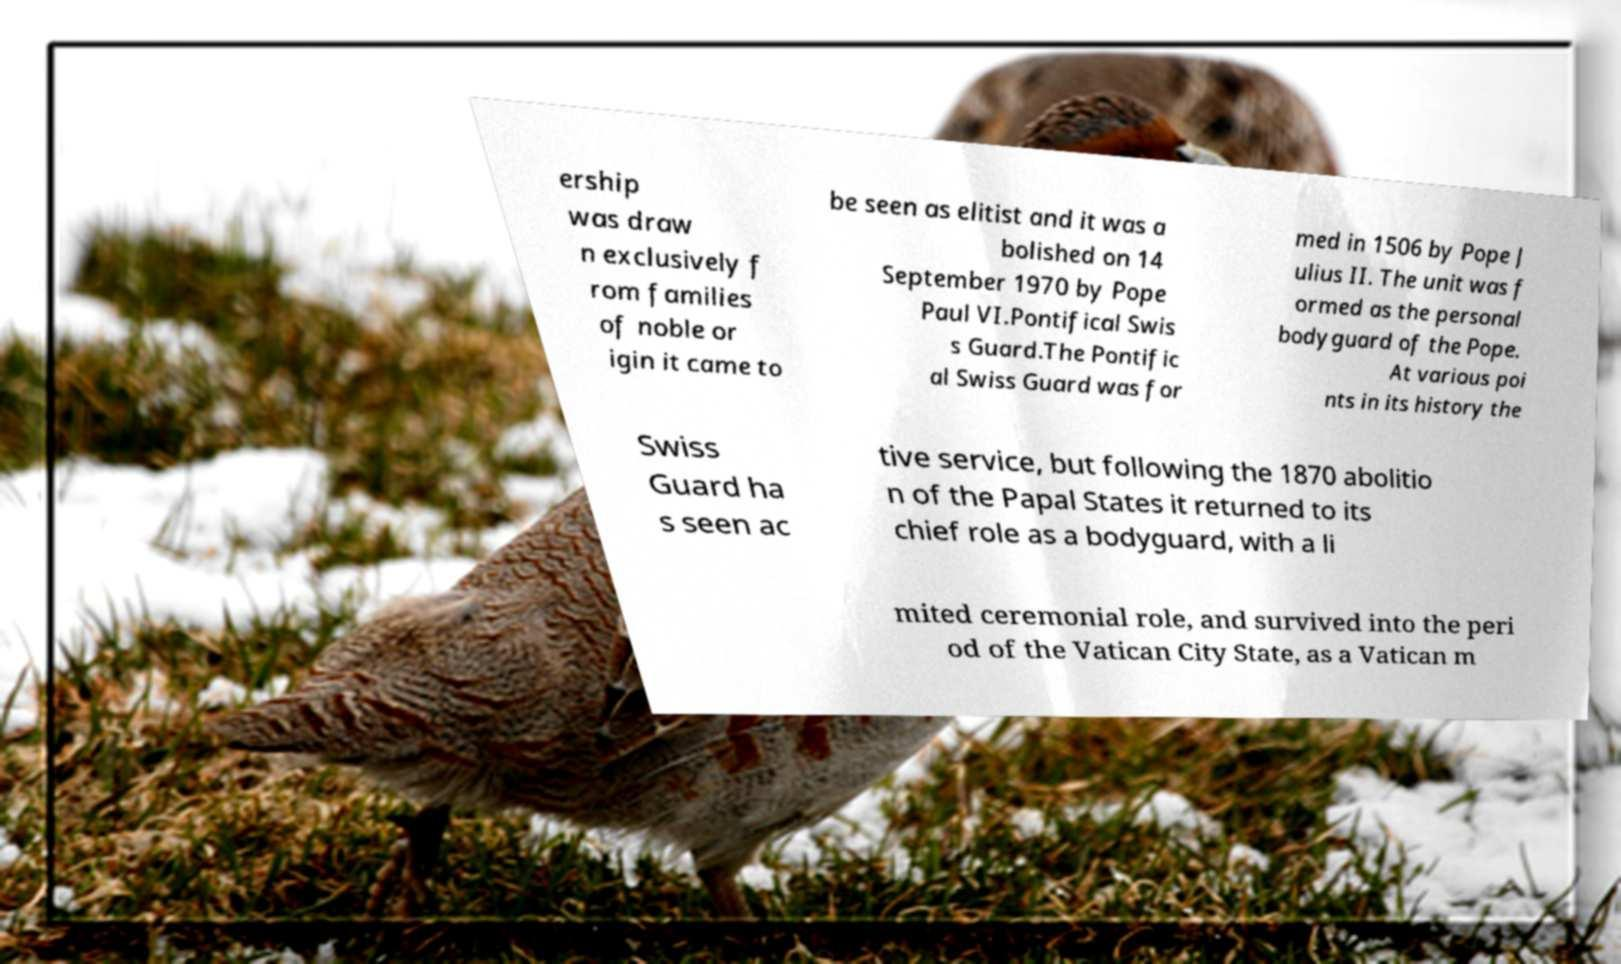For documentation purposes, I need the text within this image transcribed. Could you provide that? ership was draw n exclusively f rom families of noble or igin it came to be seen as elitist and it was a bolished on 14 September 1970 by Pope Paul VI.Pontifical Swis s Guard.The Pontific al Swiss Guard was for med in 1506 by Pope J ulius II. The unit was f ormed as the personal bodyguard of the Pope. At various poi nts in its history the Swiss Guard ha s seen ac tive service, but following the 1870 abolitio n of the Papal States it returned to its chief role as a bodyguard, with a li mited ceremonial role, and survived into the peri od of the Vatican City State, as a Vatican m 